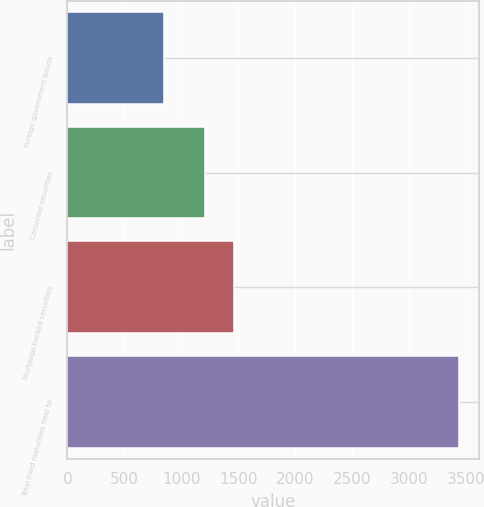Convert chart. <chart><loc_0><loc_0><loc_500><loc_500><bar_chart><fcel>Foreign government bonds<fcel>Corporate securities<fcel>Mortgage-backed securities<fcel>Total fixed maturities held to<nl><fcel>844<fcel>1206<fcel>1465.7<fcel>3441<nl></chart> 